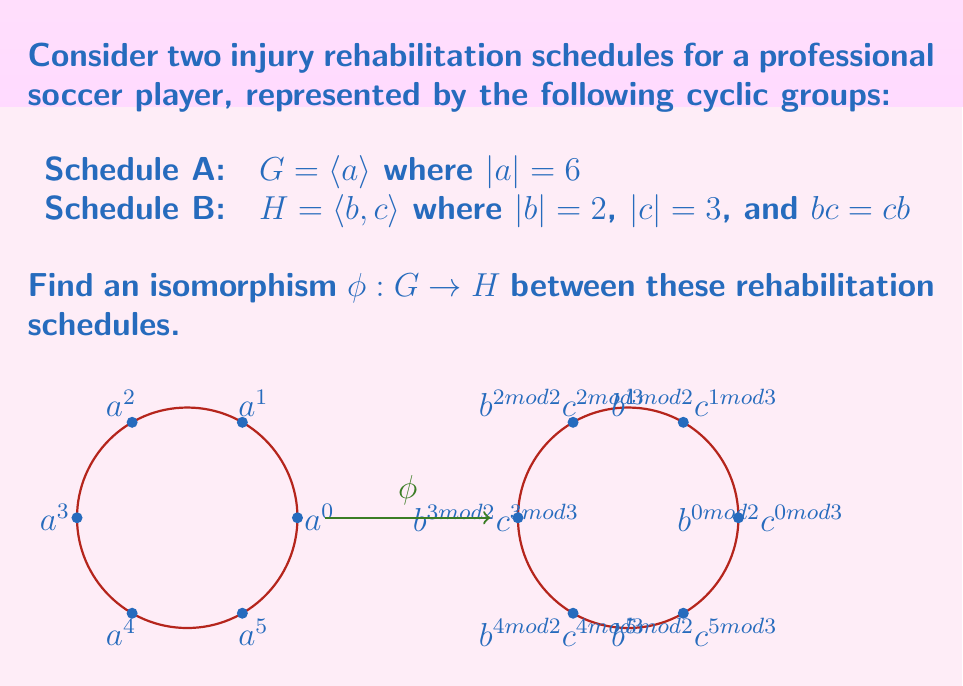Can you answer this question? To find an isomorphism between $G$ and $H$, we need to establish a bijective homomorphism that preserves the group structure. Let's approach this step-by-step:

1) First, note that both groups have order 6:
   $|G| = |\langle a \rangle| = 6$
   $|H| = |\langle b, c \rangle| = |b| \cdot |c| = 2 \cdot 3 = 6$

2) The elements of $G$ are: $\{e, a, a^2, a^3, a^4, a^5\}$

3) The elements of $H$ are: $\{e, b, c, bc, c^2, bc^2\}$

4) To define an isomorphism $\phi: G \rightarrow H$, we only need to specify where $\phi$ sends the generator $a$. The rest will follow from the homomorphism property.

5) We can define $\phi(a) = bc$. This works because $(bc)^6 = e$ in $H$, matching the order of $a$ in $G$.

6) Now we can fully define $\phi$:
   $\phi(e) = e$
   $\phi(a) = bc$
   $\phi(a^2) = (bc)^2 = b$
   $\phi(a^3) = (bc)^3 = c$
   $\phi(a^4) = (bc)^4 = bc^2$
   $\phi(a^5) = (bc)^5 = c^2$

7) To verify this is an isomorphism:
   - It's bijective: every element of $H$ is hit exactly once.
   - It's a homomorphism: $\phi(a^i \cdot a^j) = \phi(a^{i+j}) = (bc)^{i+j} = (bc)^i \cdot (bc)^j = \phi(a^i) \cdot \phi(a^j)$

Therefore, $\phi$ is an isomorphism between $G$ and $H$.
Answer: $\phi(a^k) = (bc)^k$ for $k = 0, 1, 2, 3, 4, 5$ 